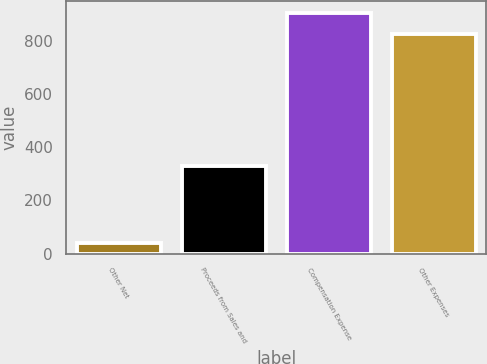Convert chart to OTSL. <chart><loc_0><loc_0><loc_500><loc_500><bar_chart><fcel>Other Net<fcel>Proceeds from Sales and<fcel>Compensation Expense<fcel>Other Expenses<nl><fcel>38.4<fcel>331.3<fcel>904.67<fcel>824.6<nl></chart> 